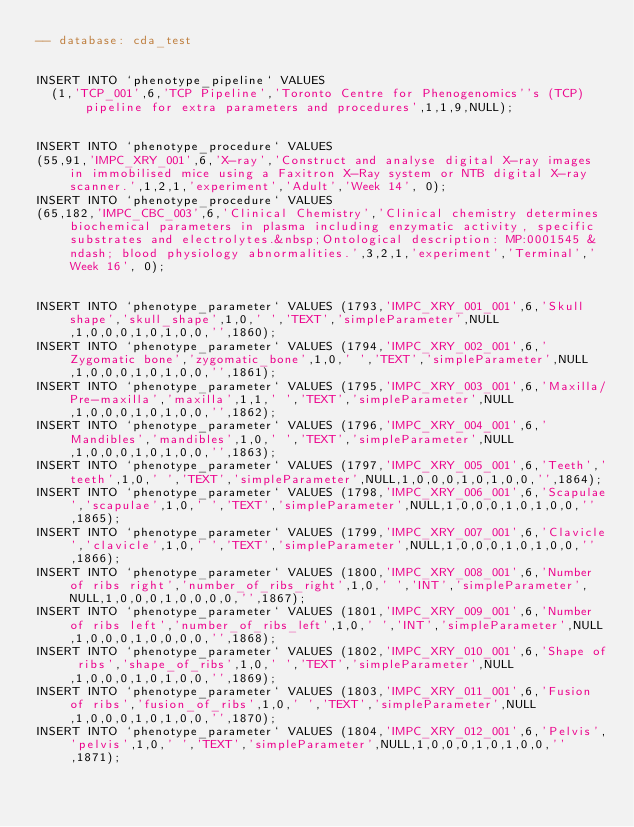Convert code to text. <code><loc_0><loc_0><loc_500><loc_500><_SQL_>-- database: cda_test


INSERT INTO `phenotype_pipeline` VALUES
  (1,'TCP_001',6,'TCP Pipeline','Toronto Centre for Phenogenomics''s (TCP) pipeline for extra parameters and procedures',1,1,9,NULL);


INSERT INTO `phenotype_procedure` VALUES
(55,91,'IMPC_XRY_001',6,'X-ray','Construct and analyse digital X-ray images in immobilised mice using a Faxitron X-Ray system or NTB digital X-ray scanner.',1,2,1,'experiment','Adult','Week 14', 0);
INSERT INTO `phenotype_procedure` VALUES
(65,182,'IMPC_CBC_003',6,'Clinical Chemistry','Clinical chemistry determines biochemical parameters in plasma including enzymatic activity, specific substrates and electrolytes.&nbsp;Ontological description: MP:0001545 &ndash; blood physiology abnormalities.',3,2,1,'experiment','Terminal','Week 16', 0);


INSERT INTO `phenotype_parameter` VALUES (1793,'IMPC_XRY_001_001',6,'Skull shape','skull_shape',1,0,' ','TEXT','simpleParameter',NULL,1,0,0,0,1,0,1,0,0,'',1860);
INSERT INTO `phenotype_parameter` VALUES (1794,'IMPC_XRY_002_001',6,'Zygomatic bone','zygomatic_bone',1,0,' ','TEXT','simpleParameter',NULL,1,0,0,0,1,0,1,0,0,'',1861);
INSERT INTO `phenotype_parameter` VALUES (1795,'IMPC_XRY_003_001',6,'Maxilla/Pre-maxilla','maxilla',1,1,' ','TEXT','simpleParameter',NULL,1,0,0,0,1,0,1,0,0,'',1862);
INSERT INTO `phenotype_parameter` VALUES (1796,'IMPC_XRY_004_001',6,'Mandibles','mandibles',1,0,' ','TEXT','simpleParameter',NULL,1,0,0,0,1,0,1,0,0,'',1863);
INSERT INTO `phenotype_parameter` VALUES (1797,'IMPC_XRY_005_001',6,'Teeth','teeth',1,0,' ','TEXT','simpleParameter',NULL,1,0,0,0,1,0,1,0,0,'',1864);
INSERT INTO `phenotype_parameter` VALUES (1798,'IMPC_XRY_006_001',6,'Scapulae','scapulae',1,0,' ','TEXT','simpleParameter',NULL,1,0,0,0,1,0,1,0,0,'',1865);
INSERT INTO `phenotype_parameter` VALUES (1799,'IMPC_XRY_007_001',6,'Clavicle','clavicle',1,0,' ','TEXT','simpleParameter',NULL,1,0,0,0,1,0,1,0,0,'',1866);
INSERT INTO `phenotype_parameter` VALUES (1800,'IMPC_XRY_008_001',6,'Number of ribs right','number_of_ribs_right',1,0,' ','INT','simpleParameter',NULL,1,0,0,0,1,0,0,0,0,'',1867);
INSERT INTO `phenotype_parameter` VALUES (1801,'IMPC_XRY_009_001',6,'Number of ribs left','number_of_ribs_left',1,0,' ','INT','simpleParameter',NULL,1,0,0,0,1,0,0,0,0,'',1868);
INSERT INTO `phenotype_parameter` VALUES (1802,'IMPC_XRY_010_001',6,'Shape of ribs','shape_of_ribs',1,0,' ','TEXT','simpleParameter',NULL,1,0,0,0,1,0,1,0,0,'',1869);
INSERT INTO `phenotype_parameter` VALUES (1803,'IMPC_XRY_011_001',6,'Fusion of ribs','fusion_of_ribs',1,0,' ','TEXT','simpleParameter',NULL,1,0,0,0,1,0,1,0,0,'',1870);
INSERT INTO `phenotype_parameter` VALUES (1804,'IMPC_XRY_012_001',6,'Pelvis','pelvis',1,0,' ','TEXT','simpleParameter',NULL,1,0,0,0,1,0,1,0,0,'',1871);</code> 